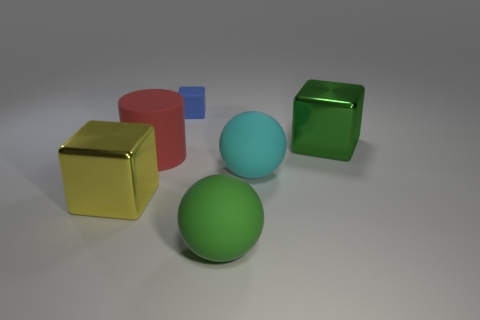What is the material of the sphere behind the large ball that is in front of the big cube that is to the left of the large green matte ball?
Offer a very short reply. Rubber. There is a block that is both behind the cylinder and to the left of the large green matte sphere; what size is it?
Provide a short and direct response. Small. There is a rubber thing that is the same shape as the large yellow shiny thing; what size is it?
Your response must be concise. Small. How many things are either big cyan rubber balls or shiny blocks that are on the left side of the green matte thing?
Your response must be concise. 2. There is a yellow thing; what shape is it?
Your answer should be compact. Cube. The big metal thing that is on the left side of the shiny thing behind the big red object is what shape?
Ensure brevity in your answer.  Cube. There is a large cylinder that is the same material as the large cyan ball; what is its color?
Your response must be concise. Red. Is there any other thing that has the same size as the blue cube?
Keep it short and to the point. No. Is the color of the big cube that is right of the big red cylinder the same as the rubber sphere that is to the left of the big cyan ball?
Offer a very short reply. Yes. Are there more metal blocks behind the big yellow metallic thing than objects behind the large green metal object?
Make the answer very short. No. 